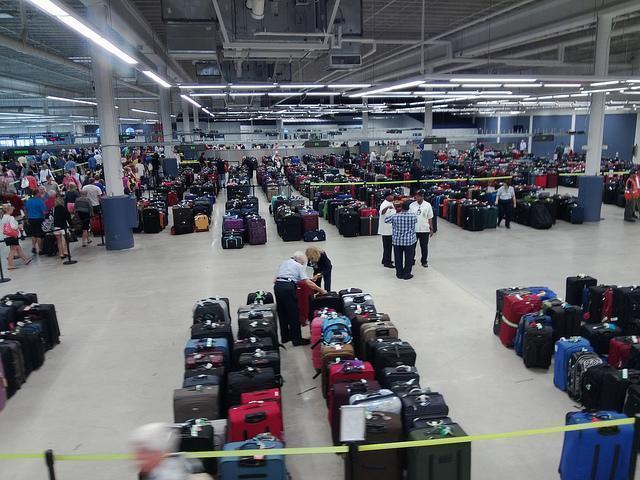What color is the tape fence around the luggage area where there is a number of luggage bags?
From the following four choices, select the correct answer to address the question.
Options: Black, yellow, red, white. Yellow. 